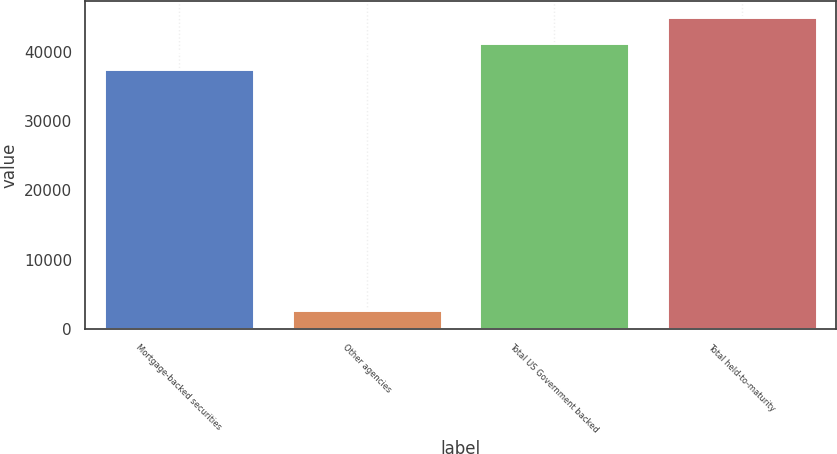Convert chart. <chart><loc_0><loc_0><loc_500><loc_500><bar_chart><fcel>Mortgage-backed securities<fcel>Other agencies<fcel>Total US Government backed<fcel>Total held-to-maturity<nl><fcel>37504<fcel>2786<fcel>41266.8<fcel>45029.6<nl></chart> 